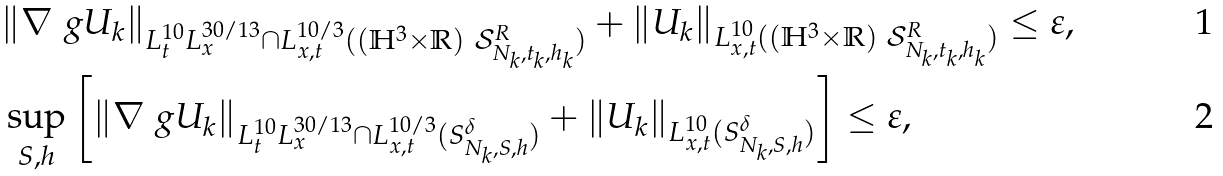<formula> <loc_0><loc_0><loc_500><loc_500>& \| \nabla _ { \ } g U _ { k } \| _ { L ^ { 1 0 } _ { t } L ^ { 3 0 / 1 3 } _ { x } \cap L ^ { 1 0 / 3 } _ { x , t } ( ( \mathbb { H } ^ { 3 } \times \mathbb { R } ) \ \mathcal { S } ^ { R } _ { N _ { k } , t _ { k } , h _ { k } } ) } + \| U _ { k } \| _ { L ^ { 1 0 } _ { x , t } ( ( \mathbb { H } ^ { 3 } \times \mathbb { R } ) \ \mathcal { S } ^ { R } _ { N _ { k } , t _ { k } , h _ { k } } ) } \leq \varepsilon , \\ & \sup _ { S , h } \left [ \| \nabla _ { \ } g U _ { k } \| _ { L ^ { 1 0 } _ { t } L ^ { 3 0 / 1 3 } _ { x } \cap L ^ { 1 0 / 3 } _ { x , t } ( S ^ { \delta } _ { N _ { k } , S , h } ) } + \| U _ { k } \| _ { L ^ { 1 0 } _ { x , t } ( S ^ { \delta } _ { N _ { k } , S , h } ) } \right ] \leq \varepsilon ,</formula> 